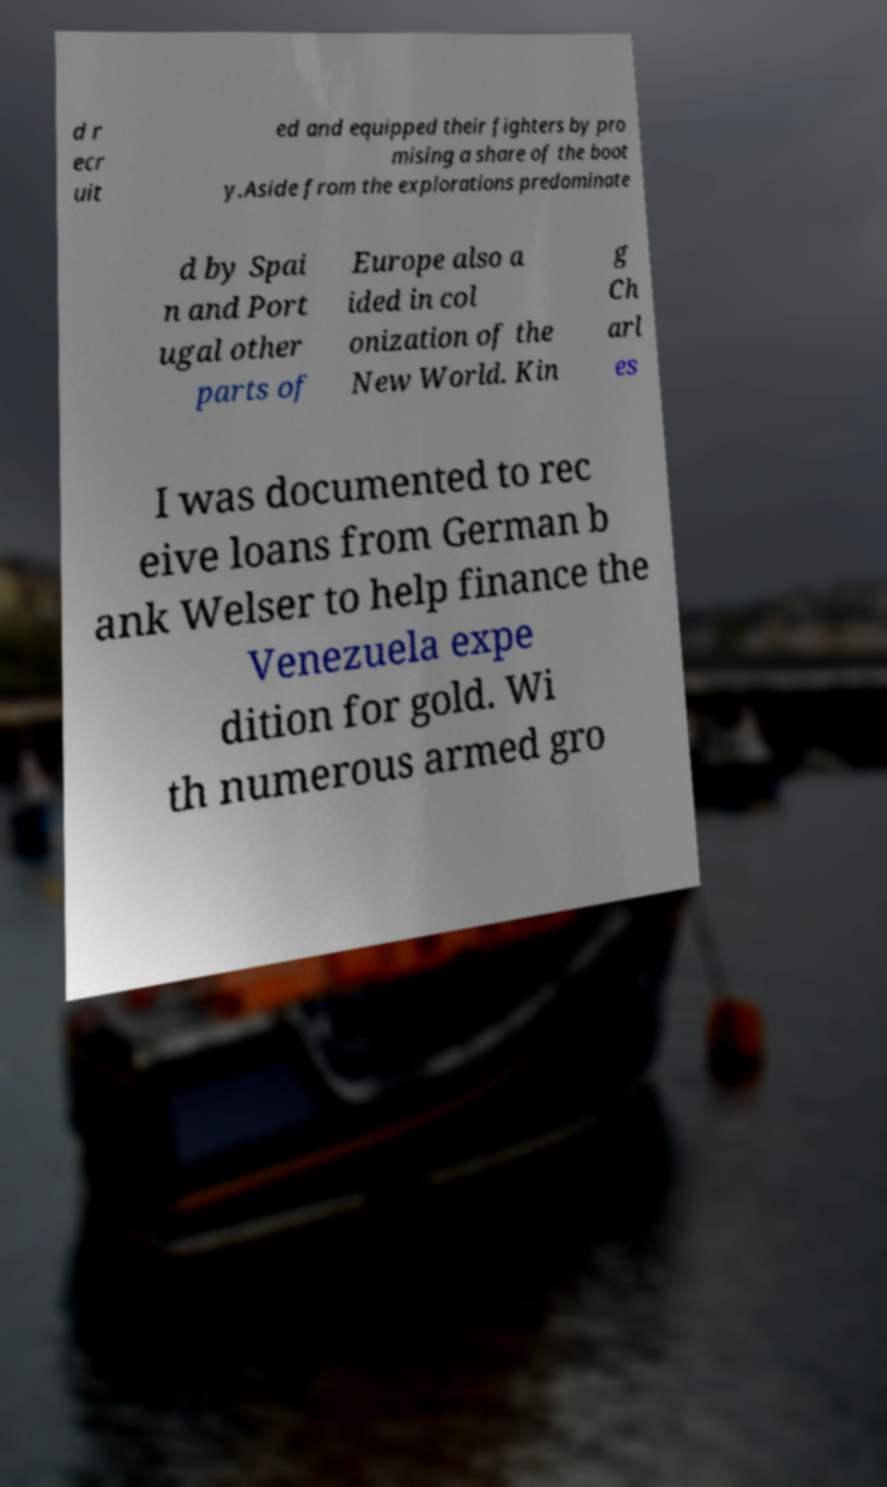There's text embedded in this image that I need extracted. Can you transcribe it verbatim? d r ecr uit ed and equipped their fighters by pro mising a share of the boot y.Aside from the explorations predominate d by Spai n and Port ugal other parts of Europe also a ided in col onization of the New World. Kin g Ch arl es I was documented to rec eive loans from German b ank Welser to help finance the Venezuela expe dition for gold. Wi th numerous armed gro 